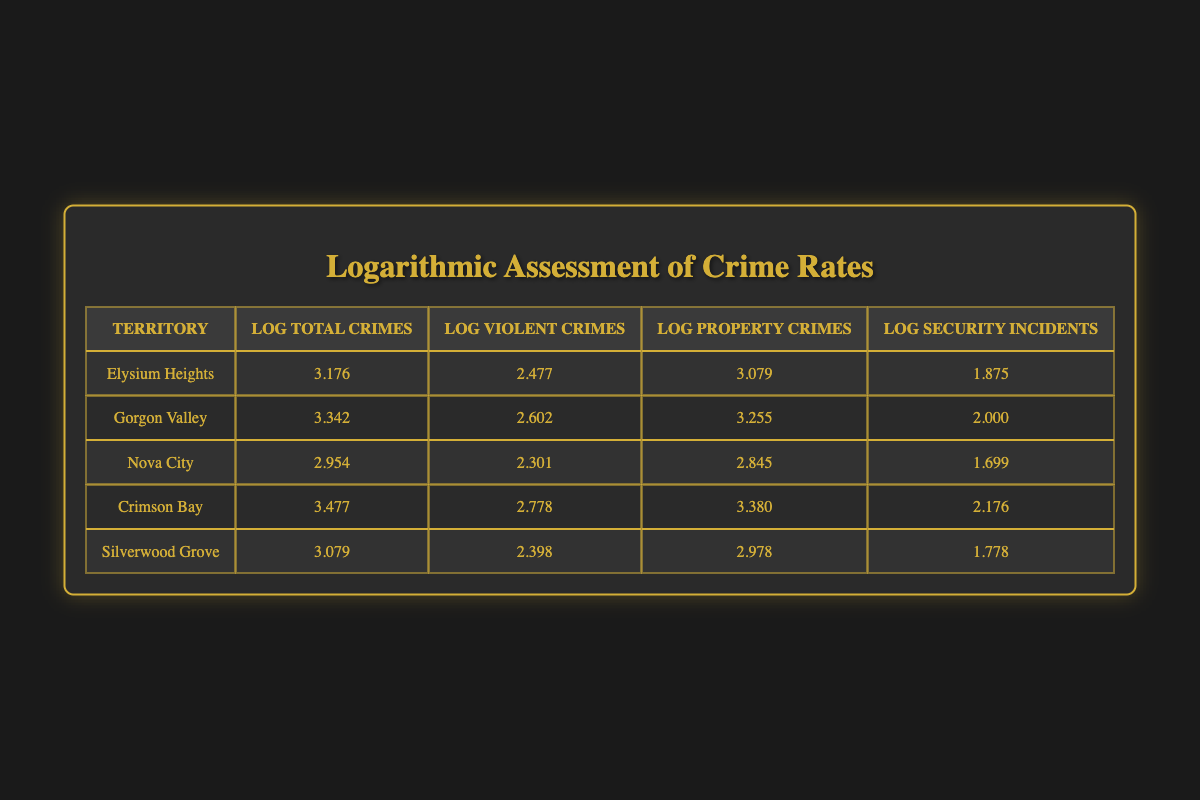What is the logarithmic value of total crimes in Crimson Bay? The table indicates that the value for Log Total Crimes in Crimson Bay is listed as 3.477.
Answer: 3.477 Which territory has the highest log value for property crimes? From the table, the highest Log Property Crimes value is found in Crimson Bay at 3.380.
Answer: Crimson Bay Is the number of log security incidents in Silverwood Grove greater than that in Nova City? According to the table, Silverwood Grove has a Log Security Incidents value of 1.778, while Nova City has a value of 1.699, confirming it is greater.
Answer: Yes What is the average log value of violent crimes across all territories? First, sum the Log Violent Crimes for all territories: (2.477 + 2.602 + 2.301 + 2.778 + 2.398) = 12.556. Then, divide by the number of territories (5) to find the average: 12.556 / 5 = 2.5112.
Answer: 2.5112 Which territory has the lowest total crime logarithmic value and what is that value? By looking through the Log Total Crimes column, Nova City has the lowest value at 2.954.
Answer: Nova City, 2.954 How many more log security incidents were recorded in Gorgon Valley compared to Nova City? The table shows Gorgon Valley with 2.000 in Log Security Incidents and Nova City with 1.699. The difference is 2.000 - 1.699 = 0.301.
Answer: 0.301 